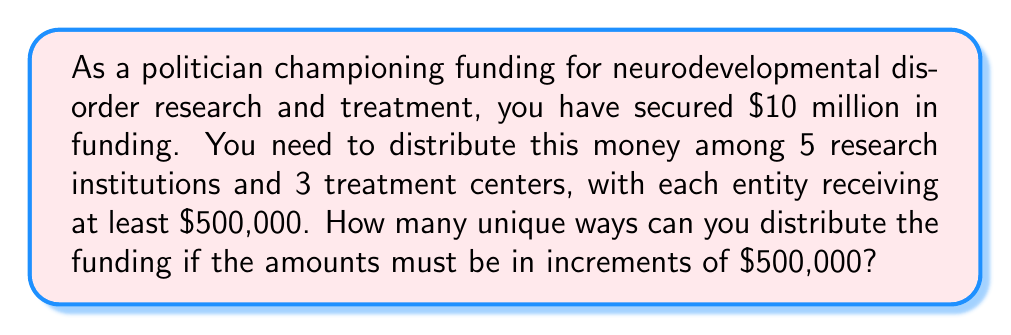Give your solution to this math problem. Let's approach this step-by-step:

1) First, we need to determine how many $500,000 units we have to distribute:
   $\frac{10,000,000}{500,000} = 20$ units

2) We need to ensure each entity (5 research institutions and 3 treatment centers, total 8) receives at least one unit. So we start by giving each entity one unit:
   $20 - 8 = 12$ units left to distribute

3) Now, we need to find the number of ways to distribute these 12 units among 8 entities. This is a classic stars and bars problem.

4) The formula for stars and bars is:
   $${n+k-1 \choose k-1}$$
   where $n$ is the number of items to distribute (stars) and $k$ is the number of groups (bars + 1)

5) In our case, $n = 12$ and $k = 8$

6) Plugging into the formula:
   $${12+8-1 \choose 8-1} = {19 \choose 7}$$

7) Calculate this combination:
   $${19 \choose 7} = \frac{19!}{7!(19-7)!} = \frac{19!}{7!12!} = 50,388$$

Therefore, there are 50,388 unique ways to distribute the funding.
Answer: 50,388 unique ways 